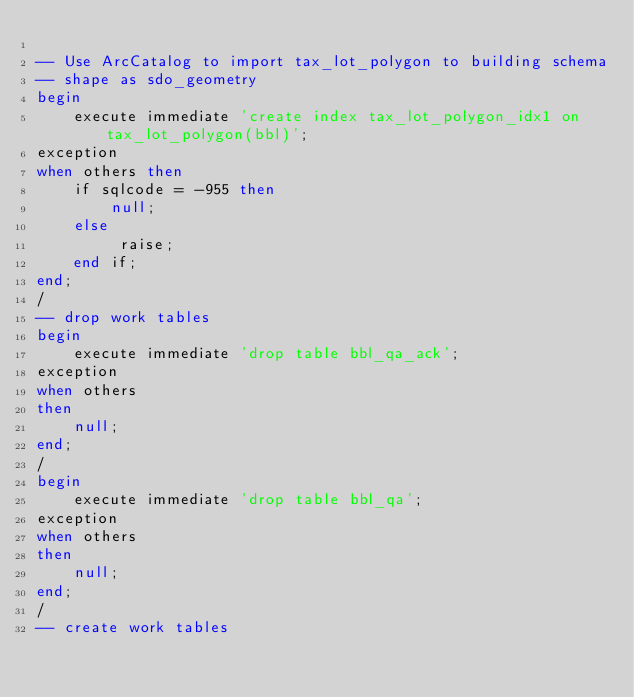<code> <loc_0><loc_0><loc_500><loc_500><_SQL_>
-- Use ArcCatalog to import tax_lot_polygon to building schema
-- shape as sdo_geometry
begin 
    execute immediate 'create index tax_lot_polygon_idx1 on tax_lot_polygon(bbl)';
exception
when others then
    if sqlcode = -955 then
        null; 
    else
         raise;
    end if;
end;
/
-- drop work tables
begin
    execute immediate 'drop table bbl_qa_ack';
exception 
when others 
then 
    null;
end;
/
begin
    execute immediate 'drop table bbl_qa';
exception 
when others 
then 
    null;
end;
/
-- create work tables</code> 